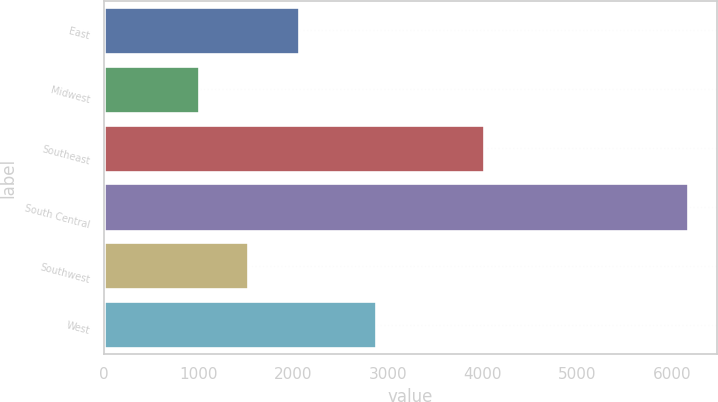Convert chart to OTSL. <chart><loc_0><loc_0><loc_500><loc_500><bar_chart><fcel>East<fcel>Midwest<fcel>Southeast<fcel>South Central<fcel>Southwest<fcel>West<nl><fcel>2066<fcel>1005<fcel>4019<fcel>6169<fcel>1521.4<fcel>2878<nl></chart> 